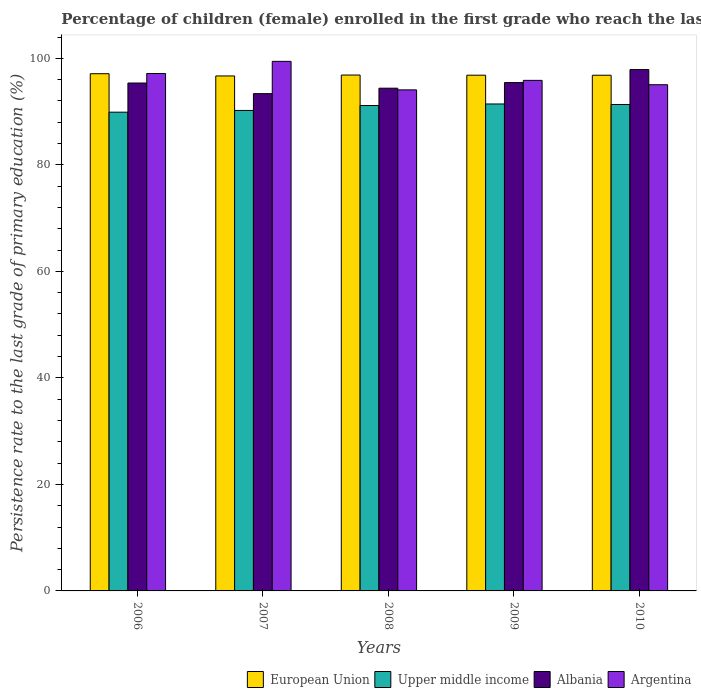How many groups of bars are there?
Provide a short and direct response. 5. Are the number of bars on each tick of the X-axis equal?
Provide a short and direct response. Yes. How many bars are there on the 3rd tick from the right?
Give a very brief answer. 4. In how many cases, is the number of bars for a given year not equal to the number of legend labels?
Make the answer very short. 0. What is the persistence rate of children in Albania in 2009?
Give a very brief answer. 95.44. Across all years, what is the maximum persistence rate of children in Albania?
Give a very brief answer. 97.89. Across all years, what is the minimum persistence rate of children in Argentina?
Keep it short and to the point. 94.08. What is the total persistence rate of children in European Union in the graph?
Give a very brief answer. 484.31. What is the difference between the persistence rate of children in Argentina in 2008 and that in 2010?
Give a very brief answer. -0.96. What is the difference between the persistence rate of children in Argentina in 2007 and the persistence rate of children in Albania in 2008?
Your response must be concise. 5.04. What is the average persistence rate of children in Argentina per year?
Your answer should be compact. 96.31. In the year 2010, what is the difference between the persistence rate of children in Albania and persistence rate of children in Argentina?
Your answer should be very brief. 2.85. In how many years, is the persistence rate of children in European Union greater than 36 %?
Offer a terse response. 5. What is the ratio of the persistence rate of children in Albania in 2006 to that in 2009?
Give a very brief answer. 1. What is the difference between the highest and the second highest persistence rate of children in Upper middle income?
Provide a succinct answer. 0.1. What is the difference between the highest and the lowest persistence rate of children in European Union?
Offer a terse response. 0.42. In how many years, is the persistence rate of children in Argentina greater than the average persistence rate of children in Argentina taken over all years?
Provide a succinct answer. 2. What does the 1st bar from the left in 2009 represents?
Make the answer very short. European Union. What does the 3rd bar from the right in 2009 represents?
Your answer should be very brief. Upper middle income. Are all the bars in the graph horizontal?
Make the answer very short. No. How many years are there in the graph?
Make the answer very short. 5. Are the values on the major ticks of Y-axis written in scientific E-notation?
Your answer should be compact. No. Does the graph contain any zero values?
Your answer should be very brief. No. Does the graph contain grids?
Provide a short and direct response. No. What is the title of the graph?
Offer a terse response. Percentage of children (female) enrolled in the first grade who reach the last grade of primary education. Does "Low income" appear as one of the legend labels in the graph?
Your answer should be very brief. No. What is the label or title of the X-axis?
Make the answer very short. Years. What is the label or title of the Y-axis?
Offer a terse response. Persistence rate to the last grade of primary education (%). What is the Persistence rate to the last grade of primary education (%) in European Union in 2006?
Your response must be concise. 97.11. What is the Persistence rate to the last grade of primary education (%) in Upper middle income in 2006?
Provide a succinct answer. 89.88. What is the Persistence rate to the last grade of primary education (%) of Albania in 2006?
Offer a very short reply. 95.36. What is the Persistence rate to the last grade of primary education (%) in Argentina in 2006?
Offer a terse response. 97.15. What is the Persistence rate to the last grade of primary education (%) of European Union in 2007?
Make the answer very short. 96.69. What is the Persistence rate to the last grade of primary education (%) in Upper middle income in 2007?
Your answer should be compact. 90.21. What is the Persistence rate to the last grade of primary education (%) of Albania in 2007?
Make the answer very short. 93.36. What is the Persistence rate to the last grade of primary education (%) of Argentina in 2007?
Provide a short and direct response. 99.43. What is the Persistence rate to the last grade of primary education (%) of European Union in 2008?
Provide a short and direct response. 96.86. What is the Persistence rate to the last grade of primary education (%) of Upper middle income in 2008?
Keep it short and to the point. 91.13. What is the Persistence rate to the last grade of primary education (%) in Albania in 2008?
Give a very brief answer. 94.39. What is the Persistence rate to the last grade of primary education (%) of Argentina in 2008?
Provide a short and direct response. 94.08. What is the Persistence rate to the last grade of primary education (%) in European Union in 2009?
Provide a succinct answer. 96.83. What is the Persistence rate to the last grade of primary education (%) of Upper middle income in 2009?
Provide a short and direct response. 91.43. What is the Persistence rate to the last grade of primary education (%) in Albania in 2009?
Your answer should be compact. 95.44. What is the Persistence rate to the last grade of primary education (%) in Argentina in 2009?
Give a very brief answer. 95.86. What is the Persistence rate to the last grade of primary education (%) of European Union in 2010?
Give a very brief answer. 96.82. What is the Persistence rate to the last grade of primary education (%) of Upper middle income in 2010?
Your answer should be compact. 91.33. What is the Persistence rate to the last grade of primary education (%) in Albania in 2010?
Ensure brevity in your answer.  97.89. What is the Persistence rate to the last grade of primary education (%) in Argentina in 2010?
Keep it short and to the point. 95.04. Across all years, what is the maximum Persistence rate to the last grade of primary education (%) in European Union?
Provide a short and direct response. 97.11. Across all years, what is the maximum Persistence rate to the last grade of primary education (%) in Upper middle income?
Offer a very short reply. 91.43. Across all years, what is the maximum Persistence rate to the last grade of primary education (%) in Albania?
Make the answer very short. 97.89. Across all years, what is the maximum Persistence rate to the last grade of primary education (%) in Argentina?
Your response must be concise. 99.43. Across all years, what is the minimum Persistence rate to the last grade of primary education (%) of European Union?
Give a very brief answer. 96.69. Across all years, what is the minimum Persistence rate to the last grade of primary education (%) in Upper middle income?
Ensure brevity in your answer.  89.88. Across all years, what is the minimum Persistence rate to the last grade of primary education (%) in Albania?
Make the answer very short. 93.36. Across all years, what is the minimum Persistence rate to the last grade of primary education (%) in Argentina?
Ensure brevity in your answer.  94.08. What is the total Persistence rate to the last grade of primary education (%) of European Union in the graph?
Your response must be concise. 484.31. What is the total Persistence rate to the last grade of primary education (%) in Upper middle income in the graph?
Provide a succinct answer. 453.98. What is the total Persistence rate to the last grade of primary education (%) in Albania in the graph?
Your response must be concise. 476.44. What is the total Persistence rate to the last grade of primary education (%) in Argentina in the graph?
Give a very brief answer. 481.55. What is the difference between the Persistence rate to the last grade of primary education (%) of European Union in 2006 and that in 2007?
Provide a succinct answer. 0.42. What is the difference between the Persistence rate to the last grade of primary education (%) in Upper middle income in 2006 and that in 2007?
Provide a short and direct response. -0.33. What is the difference between the Persistence rate to the last grade of primary education (%) in Albania in 2006 and that in 2007?
Provide a succinct answer. 1.99. What is the difference between the Persistence rate to the last grade of primary education (%) in Argentina in 2006 and that in 2007?
Ensure brevity in your answer.  -2.28. What is the difference between the Persistence rate to the last grade of primary education (%) of European Union in 2006 and that in 2008?
Keep it short and to the point. 0.25. What is the difference between the Persistence rate to the last grade of primary education (%) of Upper middle income in 2006 and that in 2008?
Your response must be concise. -1.25. What is the difference between the Persistence rate to the last grade of primary education (%) in Argentina in 2006 and that in 2008?
Your answer should be very brief. 3.07. What is the difference between the Persistence rate to the last grade of primary education (%) of European Union in 2006 and that in 2009?
Your response must be concise. 0.28. What is the difference between the Persistence rate to the last grade of primary education (%) of Upper middle income in 2006 and that in 2009?
Offer a terse response. -1.54. What is the difference between the Persistence rate to the last grade of primary education (%) of Albania in 2006 and that in 2009?
Your response must be concise. -0.08. What is the difference between the Persistence rate to the last grade of primary education (%) of Argentina in 2006 and that in 2009?
Provide a succinct answer. 1.29. What is the difference between the Persistence rate to the last grade of primary education (%) in European Union in 2006 and that in 2010?
Offer a very short reply. 0.28. What is the difference between the Persistence rate to the last grade of primary education (%) in Upper middle income in 2006 and that in 2010?
Provide a succinct answer. -1.44. What is the difference between the Persistence rate to the last grade of primary education (%) in Albania in 2006 and that in 2010?
Offer a very short reply. -2.53. What is the difference between the Persistence rate to the last grade of primary education (%) in Argentina in 2006 and that in 2010?
Keep it short and to the point. 2.11. What is the difference between the Persistence rate to the last grade of primary education (%) in European Union in 2007 and that in 2008?
Offer a very short reply. -0.17. What is the difference between the Persistence rate to the last grade of primary education (%) of Upper middle income in 2007 and that in 2008?
Offer a terse response. -0.92. What is the difference between the Persistence rate to the last grade of primary education (%) of Albania in 2007 and that in 2008?
Provide a succinct answer. -1.02. What is the difference between the Persistence rate to the last grade of primary education (%) of Argentina in 2007 and that in 2008?
Keep it short and to the point. 5.35. What is the difference between the Persistence rate to the last grade of primary education (%) of European Union in 2007 and that in 2009?
Give a very brief answer. -0.14. What is the difference between the Persistence rate to the last grade of primary education (%) in Upper middle income in 2007 and that in 2009?
Your response must be concise. -1.21. What is the difference between the Persistence rate to the last grade of primary education (%) in Albania in 2007 and that in 2009?
Give a very brief answer. -2.08. What is the difference between the Persistence rate to the last grade of primary education (%) of Argentina in 2007 and that in 2009?
Provide a short and direct response. 3.57. What is the difference between the Persistence rate to the last grade of primary education (%) in European Union in 2007 and that in 2010?
Give a very brief answer. -0.13. What is the difference between the Persistence rate to the last grade of primary education (%) of Upper middle income in 2007 and that in 2010?
Provide a succinct answer. -1.12. What is the difference between the Persistence rate to the last grade of primary education (%) in Albania in 2007 and that in 2010?
Provide a short and direct response. -4.52. What is the difference between the Persistence rate to the last grade of primary education (%) of Argentina in 2007 and that in 2010?
Give a very brief answer. 4.39. What is the difference between the Persistence rate to the last grade of primary education (%) in European Union in 2008 and that in 2009?
Make the answer very short. 0.03. What is the difference between the Persistence rate to the last grade of primary education (%) in Upper middle income in 2008 and that in 2009?
Keep it short and to the point. -0.29. What is the difference between the Persistence rate to the last grade of primary education (%) of Albania in 2008 and that in 2009?
Offer a very short reply. -1.05. What is the difference between the Persistence rate to the last grade of primary education (%) of Argentina in 2008 and that in 2009?
Make the answer very short. -1.78. What is the difference between the Persistence rate to the last grade of primary education (%) in European Union in 2008 and that in 2010?
Offer a very short reply. 0.04. What is the difference between the Persistence rate to the last grade of primary education (%) in Upper middle income in 2008 and that in 2010?
Offer a very short reply. -0.2. What is the difference between the Persistence rate to the last grade of primary education (%) of Albania in 2008 and that in 2010?
Make the answer very short. -3.5. What is the difference between the Persistence rate to the last grade of primary education (%) in Argentina in 2008 and that in 2010?
Give a very brief answer. -0.96. What is the difference between the Persistence rate to the last grade of primary education (%) in European Union in 2009 and that in 2010?
Your answer should be very brief. 0.01. What is the difference between the Persistence rate to the last grade of primary education (%) in Upper middle income in 2009 and that in 2010?
Your answer should be compact. 0.1. What is the difference between the Persistence rate to the last grade of primary education (%) in Albania in 2009 and that in 2010?
Provide a succinct answer. -2.44. What is the difference between the Persistence rate to the last grade of primary education (%) in Argentina in 2009 and that in 2010?
Offer a very short reply. 0.82. What is the difference between the Persistence rate to the last grade of primary education (%) of European Union in 2006 and the Persistence rate to the last grade of primary education (%) of Upper middle income in 2007?
Make the answer very short. 6.89. What is the difference between the Persistence rate to the last grade of primary education (%) in European Union in 2006 and the Persistence rate to the last grade of primary education (%) in Albania in 2007?
Your response must be concise. 3.74. What is the difference between the Persistence rate to the last grade of primary education (%) in European Union in 2006 and the Persistence rate to the last grade of primary education (%) in Argentina in 2007?
Your answer should be very brief. -2.32. What is the difference between the Persistence rate to the last grade of primary education (%) in Upper middle income in 2006 and the Persistence rate to the last grade of primary education (%) in Albania in 2007?
Ensure brevity in your answer.  -3.48. What is the difference between the Persistence rate to the last grade of primary education (%) in Upper middle income in 2006 and the Persistence rate to the last grade of primary education (%) in Argentina in 2007?
Provide a succinct answer. -9.54. What is the difference between the Persistence rate to the last grade of primary education (%) of Albania in 2006 and the Persistence rate to the last grade of primary education (%) of Argentina in 2007?
Ensure brevity in your answer.  -4.07. What is the difference between the Persistence rate to the last grade of primary education (%) in European Union in 2006 and the Persistence rate to the last grade of primary education (%) in Upper middle income in 2008?
Keep it short and to the point. 5.97. What is the difference between the Persistence rate to the last grade of primary education (%) of European Union in 2006 and the Persistence rate to the last grade of primary education (%) of Albania in 2008?
Provide a succinct answer. 2.72. What is the difference between the Persistence rate to the last grade of primary education (%) of European Union in 2006 and the Persistence rate to the last grade of primary education (%) of Argentina in 2008?
Give a very brief answer. 3.03. What is the difference between the Persistence rate to the last grade of primary education (%) of Upper middle income in 2006 and the Persistence rate to the last grade of primary education (%) of Albania in 2008?
Your answer should be compact. -4.5. What is the difference between the Persistence rate to the last grade of primary education (%) of Upper middle income in 2006 and the Persistence rate to the last grade of primary education (%) of Argentina in 2008?
Provide a succinct answer. -4.19. What is the difference between the Persistence rate to the last grade of primary education (%) in Albania in 2006 and the Persistence rate to the last grade of primary education (%) in Argentina in 2008?
Make the answer very short. 1.28. What is the difference between the Persistence rate to the last grade of primary education (%) of European Union in 2006 and the Persistence rate to the last grade of primary education (%) of Upper middle income in 2009?
Keep it short and to the point. 5.68. What is the difference between the Persistence rate to the last grade of primary education (%) in European Union in 2006 and the Persistence rate to the last grade of primary education (%) in Albania in 2009?
Offer a terse response. 1.66. What is the difference between the Persistence rate to the last grade of primary education (%) of European Union in 2006 and the Persistence rate to the last grade of primary education (%) of Argentina in 2009?
Provide a succinct answer. 1.25. What is the difference between the Persistence rate to the last grade of primary education (%) in Upper middle income in 2006 and the Persistence rate to the last grade of primary education (%) in Albania in 2009?
Ensure brevity in your answer.  -5.56. What is the difference between the Persistence rate to the last grade of primary education (%) of Upper middle income in 2006 and the Persistence rate to the last grade of primary education (%) of Argentina in 2009?
Your answer should be compact. -5.97. What is the difference between the Persistence rate to the last grade of primary education (%) in Albania in 2006 and the Persistence rate to the last grade of primary education (%) in Argentina in 2009?
Make the answer very short. -0.5. What is the difference between the Persistence rate to the last grade of primary education (%) in European Union in 2006 and the Persistence rate to the last grade of primary education (%) in Upper middle income in 2010?
Offer a very short reply. 5.78. What is the difference between the Persistence rate to the last grade of primary education (%) of European Union in 2006 and the Persistence rate to the last grade of primary education (%) of Albania in 2010?
Offer a very short reply. -0.78. What is the difference between the Persistence rate to the last grade of primary education (%) of European Union in 2006 and the Persistence rate to the last grade of primary education (%) of Argentina in 2010?
Ensure brevity in your answer.  2.07. What is the difference between the Persistence rate to the last grade of primary education (%) in Upper middle income in 2006 and the Persistence rate to the last grade of primary education (%) in Albania in 2010?
Your answer should be compact. -8. What is the difference between the Persistence rate to the last grade of primary education (%) of Upper middle income in 2006 and the Persistence rate to the last grade of primary education (%) of Argentina in 2010?
Offer a very short reply. -5.16. What is the difference between the Persistence rate to the last grade of primary education (%) of Albania in 2006 and the Persistence rate to the last grade of primary education (%) of Argentina in 2010?
Provide a short and direct response. 0.32. What is the difference between the Persistence rate to the last grade of primary education (%) of European Union in 2007 and the Persistence rate to the last grade of primary education (%) of Upper middle income in 2008?
Your answer should be compact. 5.56. What is the difference between the Persistence rate to the last grade of primary education (%) in European Union in 2007 and the Persistence rate to the last grade of primary education (%) in Albania in 2008?
Your response must be concise. 2.3. What is the difference between the Persistence rate to the last grade of primary education (%) in European Union in 2007 and the Persistence rate to the last grade of primary education (%) in Argentina in 2008?
Make the answer very short. 2.61. What is the difference between the Persistence rate to the last grade of primary education (%) of Upper middle income in 2007 and the Persistence rate to the last grade of primary education (%) of Albania in 2008?
Make the answer very short. -4.18. What is the difference between the Persistence rate to the last grade of primary education (%) in Upper middle income in 2007 and the Persistence rate to the last grade of primary education (%) in Argentina in 2008?
Provide a short and direct response. -3.86. What is the difference between the Persistence rate to the last grade of primary education (%) in Albania in 2007 and the Persistence rate to the last grade of primary education (%) in Argentina in 2008?
Your answer should be compact. -0.71. What is the difference between the Persistence rate to the last grade of primary education (%) of European Union in 2007 and the Persistence rate to the last grade of primary education (%) of Upper middle income in 2009?
Your answer should be compact. 5.26. What is the difference between the Persistence rate to the last grade of primary education (%) in European Union in 2007 and the Persistence rate to the last grade of primary education (%) in Albania in 2009?
Make the answer very short. 1.25. What is the difference between the Persistence rate to the last grade of primary education (%) of European Union in 2007 and the Persistence rate to the last grade of primary education (%) of Argentina in 2009?
Your answer should be very brief. 0.83. What is the difference between the Persistence rate to the last grade of primary education (%) of Upper middle income in 2007 and the Persistence rate to the last grade of primary education (%) of Albania in 2009?
Your response must be concise. -5.23. What is the difference between the Persistence rate to the last grade of primary education (%) in Upper middle income in 2007 and the Persistence rate to the last grade of primary education (%) in Argentina in 2009?
Keep it short and to the point. -5.64. What is the difference between the Persistence rate to the last grade of primary education (%) of Albania in 2007 and the Persistence rate to the last grade of primary education (%) of Argentina in 2009?
Your response must be concise. -2.49. What is the difference between the Persistence rate to the last grade of primary education (%) of European Union in 2007 and the Persistence rate to the last grade of primary education (%) of Upper middle income in 2010?
Your response must be concise. 5.36. What is the difference between the Persistence rate to the last grade of primary education (%) in European Union in 2007 and the Persistence rate to the last grade of primary education (%) in Albania in 2010?
Ensure brevity in your answer.  -1.2. What is the difference between the Persistence rate to the last grade of primary education (%) of European Union in 2007 and the Persistence rate to the last grade of primary education (%) of Argentina in 2010?
Ensure brevity in your answer.  1.65. What is the difference between the Persistence rate to the last grade of primary education (%) in Upper middle income in 2007 and the Persistence rate to the last grade of primary education (%) in Albania in 2010?
Keep it short and to the point. -7.67. What is the difference between the Persistence rate to the last grade of primary education (%) in Upper middle income in 2007 and the Persistence rate to the last grade of primary education (%) in Argentina in 2010?
Make the answer very short. -4.83. What is the difference between the Persistence rate to the last grade of primary education (%) of Albania in 2007 and the Persistence rate to the last grade of primary education (%) of Argentina in 2010?
Give a very brief answer. -1.68. What is the difference between the Persistence rate to the last grade of primary education (%) in European Union in 2008 and the Persistence rate to the last grade of primary education (%) in Upper middle income in 2009?
Give a very brief answer. 5.43. What is the difference between the Persistence rate to the last grade of primary education (%) of European Union in 2008 and the Persistence rate to the last grade of primary education (%) of Albania in 2009?
Keep it short and to the point. 1.42. What is the difference between the Persistence rate to the last grade of primary education (%) of European Union in 2008 and the Persistence rate to the last grade of primary education (%) of Argentina in 2009?
Ensure brevity in your answer.  1. What is the difference between the Persistence rate to the last grade of primary education (%) of Upper middle income in 2008 and the Persistence rate to the last grade of primary education (%) of Albania in 2009?
Give a very brief answer. -4.31. What is the difference between the Persistence rate to the last grade of primary education (%) of Upper middle income in 2008 and the Persistence rate to the last grade of primary education (%) of Argentina in 2009?
Offer a terse response. -4.72. What is the difference between the Persistence rate to the last grade of primary education (%) in Albania in 2008 and the Persistence rate to the last grade of primary education (%) in Argentina in 2009?
Your answer should be compact. -1.47. What is the difference between the Persistence rate to the last grade of primary education (%) in European Union in 2008 and the Persistence rate to the last grade of primary education (%) in Upper middle income in 2010?
Make the answer very short. 5.53. What is the difference between the Persistence rate to the last grade of primary education (%) of European Union in 2008 and the Persistence rate to the last grade of primary education (%) of Albania in 2010?
Ensure brevity in your answer.  -1.03. What is the difference between the Persistence rate to the last grade of primary education (%) of European Union in 2008 and the Persistence rate to the last grade of primary education (%) of Argentina in 2010?
Offer a very short reply. 1.82. What is the difference between the Persistence rate to the last grade of primary education (%) in Upper middle income in 2008 and the Persistence rate to the last grade of primary education (%) in Albania in 2010?
Provide a succinct answer. -6.75. What is the difference between the Persistence rate to the last grade of primary education (%) of Upper middle income in 2008 and the Persistence rate to the last grade of primary education (%) of Argentina in 2010?
Provide a short and direct response. -3.91. What is the difference between the Persistence rate to the last grade of primary education (%) of Albania in 2008 and the Persistence rate to the last grade of primary education (%) of Argentina in 2010?
Provide a short and direct response. -0.65. What is the difference between the Persistence rate to the last grade of primary education (%) of European Union in 2009 and the Persistence rate to the last grade of primary education (%) of Upper middle income in 2010?
Ensure brevity in your answer.  5.5. What is the difference between the Persistence rate to the last grade of primary education (%) of European Union in 2009 and the Persistence rate to the last grade of primary education (%) of Albania in 2010?
Offer a very short reply. -1.06. What is the difference between the Persistence rate to the last grade of primary education (%) in European Union in 2009 and the Persistence rate to the last grade of primary education (%) in Argentina in 2010?
Your answer should be very brief. 1.79. What is the difference between the Persistence rate to the last grade of primary education (%) of Upper middle income in 2009 and the Persistence rate to the last grade of primary education (%) of Albania in 2010?
Your answer should be compact. -6.46. What is the difference between the Persistence rate to the last grade of primary education (%) in Upper middle income in 2009 and the Persistence rate to the last grade of primary education (%) in Argentina in 2010?
Make the answer very short. -3.61. What is the difference between the Persistence rate to the last grade of primary education (%) of Albania in 2009 and the Persistence rate to the last grade of primary education (%) of Argentina in 2010?
Make the answer very short. 0.4. What is the average Persistence rate to the last grade of primary education (%) of European Union per year?
Offer a very short reply. 96.86. What is the average Persistence rate to the last grade of primary education (%) in Upper middle income per year?
Ensure brevity in your answer.  90.8. What is the average Persistence rate to the last grade of primary education (%) in Albania per year?
Your response must be concise. 95.29. What is the average Persistence rate to the last grade of primary education (%) in Argentina per year?
Make the answer very short. 96.31. In the year 2006, what is the difference between the Persistence rate to the last grade of primary education (%) in European Union and Persistence rate to the last grade of primary education (%) in Upper middle income?
Your answer should be compact. 7.22. In the year 2006, what is the difference between the Persistence rate to the last grade of primary education (%) in European Union and Persistence rate to the last grade of primary education (%) in Albania?
Keep it short and to the point. 1.75. In the year 2006, what is the difference between the Persistence rate to the last grade of primary education (%) in European Union and Persistence rate to the last grade of primary education (%) in Argentina?
Your answer should be compact. -0.04. In the year 2006, what is the difference between the Persistence rate to the last grade of primary education (%) of Upper middle income and Persistence rate to the last grade of primary education (%) of Albania?
Provide a succinct answer. -5.47. In the year 2006, what is the difference between the Persistence rate to the last grade of primary education (%) in Upper middle income and Persistence rate to the last grade of primary education (%) in Argentina?
Provide a short and direct response. -7.26. In the year 2006, what is the difference between the Persistence rate to the last grade of primary education (%) of Albania and Persistence rate to the last grade of primary education (%) of Argentina?
Keep it short and to the point. -1.79. In the year 2007, what is the difference between the Persistence rate to the last grade of primary education (%) in European Union and Persistence rate to the last grade of primary education (%) in Upper middle income?
Your response must be concise. 6.48. In the year 2007, what is the difference between the Persistence rate to the last grade of primary education (%) of European Union and Persistence rate to the last grade of primary education (%) of Albania?
Your answer should be very brief. 3.32. In the year 2007, what is the difference between the Persistence rate to the last grade of primary education (%) of European Union and Persistence rate to the last grade of primary education (%) of Argentina?
Ensure brevity in your answer.  -2.74. In the year 2007, what is the difference between the Persistence rate to the last grade of primary education (%) in Upper middle income and Persistence rate to the last grade of primary education (%) in Albania?
Offer a terse response. -3.15. In the year 2007, what is the difference between the Persistence rate to the last grade of primary education (%) in Upper middle income and Persistence rate to the last grade of primary education (%) in Argentina?
Provide a succinct answer. -9.22. In the year 2007, what is the difference between the Persistence rate to the last grade of primary education (%) of Albania and Persistence rate to the last grade of primary education (%) of Argentina?
Give a very brief answer. -6.06. In the year 2008, what is the difference between the Persistence rate to the last grade of primary education (%) in European Union and Persistence rate to the last grade of primary education (%) in Upper middle income?
Make the answer very short. 5.73. In the year 2008, what is the difference between the Persistence rate to the last grade of primary education (%) in European Union and Persistence rate to the last grade of primary education (%) in Albania?
Offer a terse response. 2.47. In the year 2008, what is the difference between the Persistence rate to the last grade of primary education (%) in European Union and Persistence rate to the last grade of primary education (%) in Argentina?
Your answer should be very brief. 2.78. In the year 2008, what is the difference between the Persistence rate to the last grade of primary education (%) of Upper middle income and Persistence rate to the last grade of primary education (%) of Albania?
Keep it short and to the point. -3.25. In the year 2008, what is the difference between the Persistence rate to the last grade of primary education (%) of Upper middle income and Persistence rate to the last grade of primary education (%) of Argentina?
Offer a terse response. -2.94. In the year 2008, what is the difference between the Persistence rate to the last grade of primary education (%) in Albania and Persistence rate to the last grade of primary education (%) in Argentina?
Offer a very short reply. 0.31. In the year 2009, what is the difference between the Persistence rate to the last grade of primary education (%) of European Union and Persistence rate to the last grade of primary education (%) of Upper middle income?
Ensure brevity in your answer.  5.4. In the year 2009, what is the difference between the Persistence rate to the last grade of primary education (%) of European Union and Persistence rate to the last grade of primary education (%) of Albania?
Your answer should be compact. 1.39. In the year 2009, what is the difference between the Persistence rate to the last grade of primary education (%) of European Union and Persistence rate to the last grade of primary education (%) of Argentina?
Give a very brief answer. 0.97. In the year 2009, what is the difference between the Persistence rate to the last grade of primary education (%) of Upper middle income and Persistence rate to the last grade of primary education (%) of Albania?
Make the answer very short. -4.02. In the year 2009, what is the difference between the Persistence rate to the last grade of primary education (%) in Upper middle income and Persistence rate to the last grade of primary education (%) in Argentina?
Your answer should be very brief. -4.43. In the year 2009, what is the difference between the Persistence rate to the last grade of primary education (%) in Albania and Persistence rate to the last grade of primary education (%) in Argentina?
Provide a succinct answer. -0.41. In the year 2010, what is the difference between the Persistence rate to the last grade of primary education (%) of European Union and Persistence rate to the last grade of primary education (%) of Upper middle income?
Your answer should be very brief. 5.49. In the year 2010, what is the difference between the Persistence rate to the last grade of primary education (%) of European Union and Persistence rate to the last grade of primary education (%) of Albania?
Offer a terse response. -1.06. In the year 2010, what is the difference between the Persistence rate to the last grade of primary education (%) of European Union and Persistence rate to the last grade of primary education (%) of Argentina?
Your answer should be very brief. 1.78. In the year 2010, what is the difference between the Persistence rate to the last grade of primary education (%) of Upper middle income and Persistence rate to the last grade of primary education (%) of Albania?
Your answer should be compact. -6.56. In the year 2010, what is the difference between the Persistence rate to the last grade of primary education (%) in Upper middle income and Persistence rate to the last grade of primary education (%) in Argentina?
Provide a short and direct response. -3.71. In the year 2010, what is the difference between the Persistence rate to the last grade of primary education (%) in Albania and Persistence rate to the last grade of primary education (%) in Argentina?
Your response must be concise. 2.85. What is the ratio of the Persistence rate to the last grade of primary education (%) of Albania in 2006 to that in 2007?
Keep it short and to the point. 1.02. What is the ratio of the Persistence rate to the last grade of primary education (%) of Argentina in 2006 to that in 2007?
Offer a terse response. 0.98. What is the ratio of the Persistence rate to the last grade of primary education (%) in European Union in 2006 to that in 2008?
Ensure brevity in your answer.  1. What is the ratio of the Persistence rate to the last grade of primary education (%) of Upper middle income in 2006 to that in 2008?
Your answer should be very brief. 0.99. What is the ratio of the Persistence rate to the last grade of primary education (%) in Albania in 2006 to that in 2008?
Your answer should be compact. 1.01. What is the ratio of the Persistence rate to the last grade of primary education (%) in Argentina in 2006 to that in 2008?
Give a very brief answer. 1.03. What is the ratio of the Persistence rate to the last grade of primary education (%) of European Union in 2006 to that in 2009?
Your answer should be very brief. 1. What is the ratio of the Persistence rate to the last grade of primary education (%) of Upper middle income in 2006 to that in 2009?
Offer a terse response. 0.98. What is the ratio of the Persistence rate to the last grade of primary education (%) in Albania in 2006 to that in 2009?
Your answer should be compact. 1. What is the ratio of the Persistence rate to the last grade of primary education (%) of Argentina in 2006 to that in 2009?
Provide a succinct answer. 1.01. What is the ratio of the Persistence rate to the last grade of primary education (%) of European Union in 2006 to that in 2010?
Provide a succinct answer. 1. What is the ratio of the Persistence rate to the last grade of primary education (%) of Upper middle income in 2006 to that in 2010?
Ensure brevity in your answer.  0.98. What is the ratio of the Persistence rate to the last grade of primary education (%) in Albania in 2006 to that in 2010?
Ensure brevity in your answer.  0.97. What is the ratio of the Persistence rate to the last grade of primary education (%) of Argentina in 2006 to that in 2010?
Keep it short and to the point. 1.02. What is the ratio of the Persistence rate to the last grade of primary education (%) of Upper middle income in 2007 to that in 2008?
Provide a succinct answer. 0.99. What is the ratio of the Persistence rate to the last grade of primary education (%) in Albania in 2007 to that in 2008?
Your answer should be compact. 0.99. What is the ratio of the Persistence rate to the last grade of primary education (%) of Argentina in 2007 to that in 2008?
Keep it short and to the point. 1.06. What is the ratio of the Persistence rate to the last grade of primary education (%) of European Union in 2007 to that in 2009?
Give a very brief answer. 1. What is the ratio of the Persistence rate to the last grade of primary education (%) of Upper middle income in 2007 to that in 2009?
Your answer should be compact. 0.99. What is the ratio of the Persistence rate to the last grade of primary education (%) of Albania in 2007 to that in 2009?
Your answer should be compact. 0.98. What is the ratio of the Persistence rate to the last grade of primary education (%) in Argentina in 2007 to that in 2009?
Your response must be concise. 1.04. What is the ratio of the Persistence rate to the last grade of primary education (%) in European Union in 2007 to that in 2010?
Provide a succinct answer. 1. What is the ratio of the Persistence rate to the last grade of primary education (%) of Albania in 2007 to that in 2010?
Provide a short and direct response. 0.95. What is the ratio of the Persistence rate to the last grade of primary education (%) of Argentina in 2007 to that in 2010?
Give a very brief answer. 1.05. What is the ratio of the Persistence rate to the last grade of primary education (%) of European Union in 2008 to that in 2009?
Provide a short and direct response. 1. What is the ratio of the Persistence rate to the last grade of primary education (%) in Argentina in 2008 to that in 2009?
Give a very brief answer. 0.98. What is the ratio of the Persistence rate to the last grade of primary education (%) in European Union in 2008 to that in 2010?
Offer a terse response. 1. What is the ratio of the Persistence rate to the last grade of primary education (%) in Upper middle income in 2009 to that in 2010?
Your answer should be compact. 1. What is the ratio of the Persistence rate to the last grade of primary education (%) in Argentina in 2009 to that in 2010?
Your answer should be very brief. 1.01. What is the difference between the highest and the second highest Persistence rate to the last grade of primary education (%) of European Union?
Make the answer very short. 0.25. What is the difference between the highest and the second highest Persistence rate to the last grade of primary education (%) in Upper middle income?
Your answer should be compact. 0.1. What is the difference between the highest and the second highest Persistence rate to the last grade of primary education (%) of Albania?
Ensure brevity in your answer.  2.44. What is the difference between the highest and the second highest Persistence rate to the last grade of primary education (%) of Argentina?
Make the answer very short. 2.28. What is the difference between the highest and the lowest Persistence rate to the last grade of primary education (%) of European Union?
Offer a terse response. 0.42. What is the difference between the highest and the lowest Persistence rate to the last grade of primary education (%) of Upper middle income?
Offer a very short reply. 1.54. What is the difference between the highest and the lowest Persistence rate to the last grade of primary education (%) of Albania?
Provide a succinct answer. 4.52. What is the difference between the highest and the lowest Persistence rate to the last grade of primary education (%) in Argentina?
Your response must be concise. 5.35. 